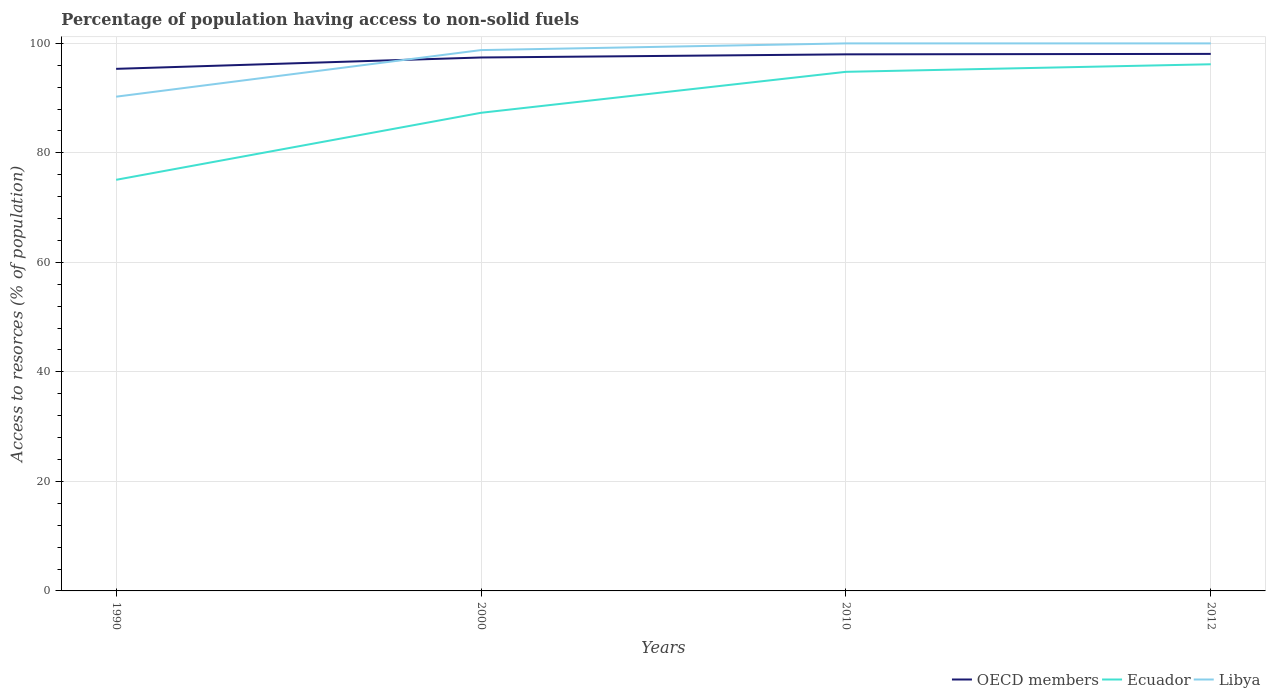Is the number of lines equal to the number of legend labels?
Your answer should be compact. Yes. Across all years, what is the maximum percentage of population having access to non-solid fuels in OECD members?
Keep it short and to the point. 95.34. What is the total percentage of population having access to non-solid fuels in Ecuador in the graph?
Offer a terse response. -21.1. What is the difference between the highest and the second highest percentage of population having access to non-solid fuels in Ecuador?
Offer a terse response. 21.1. What is the difference between the highest and the lowest percentage of population having access to non-solid fuels in Libya?
Make the answer very short. 3. Is the percentage of population having access to non-solid fuels in OECD members strictly greater than the percentage of population having access to non-solid fuels in Ecuador over the years?
Make the answer very short. No. Are the values on the major ticks of Y-axis written in scientific E-notation?
Give a very brief answer. No. Where does the legend appear in the graph?
Make the answer very short. Bottom right. How many legend labels are there?
Make the answer very short. 3. How are the legend labels stacked?
Offer a terse response. Horizontal. What is the title of the graph?
Your answer should be compact. Percentage of population having access to non-solid fuels. Does "Solomon Islands" appear as one of the legend labels in the graph?
Offer a very short reply. No. What is the label or title of the X-axis?
Provide a succinct answer. Years. What is the label or title of the Y-axis?
Keep it short and to the point. Access to resorces (% of population). What is the Access to resorces (% of population) in OECD members in 1990?
Make the answer very short. 95.34. What is the Access to resorces (% of population) in Ecuador in 1990?
Make the answer very short. 75.08. What is the Access to resorces (% of population) of Libya in 1990?
Offer a very short reply. 90.26. What is the Access to resorces (% of population) of OECD members in 2000?
Provide a short and direct response. 97.42. What is the Access to resorces (% of population) of Ecuador in 2000?
Offer a very short reply. 87.32. What is the Access to resorces (% of population) in Libya in 2000?
Provide a short and direct response. 98.77. What is the Access to resorces (% of population) of OECD members in 2010?
Your answer should be very brief. 97.99. What is the Access to resorces (% of population) in Ecuador in 2010?
Provide a short and direct response. 94.8. What is the Access to resorces (% of population) of Libya in 2010?
Give a very brief answer. 99.99. What is the Access to resorces (% of population) of OECD members in 2012?
Provide a short and direct response. 98.07. What is the Access to resorces (% of population) in Ecuador in 2012?
Offer a very short reply. 96.18. What is the Access to resorces (% of population) in Libya in 2012?
Give a very brief answer. 99.99. Across all years, what is the maximum Access to resorces (% of population) of OECD members?
Your response must be concise. 98.07. Across all years, what is the maximum Access to resorces (% of population) in Ecuador?
Give a very brief answer. 96.18. Across all years, what is the maximum Access to resorces (% of population) of Libya?
Make the answer very short. 99.99. Across all years, what is the minimum Access to resorces (% of population) in OECD members?
Provide a succinct answer. 95.34. Across all years, what is the minimum Access to resorces (% of population) in Ecuador?
Provide a succinct answer. 75.08. Across all years, what is the minimum Access to resorces (% of population) in Libya?
Keep it short and to the point. 90.26. What is the total Access to resorces (% of population) in OECD members in the graph?
Your response must be concise. 388.83. What is the total Access to resorces (% of population) of Ecuador in the graph?
Provide a succinct answer. 353.37. What is the total Access to resorces (% of population) of Libya in the graph?
Provide a succinct answer. 389.01. What is the difference between the Access to resorces (% of population) of OECD members in 1990 and that in 2000?
Ensure brevity in your answer.  -2.07. What is the difference between the Access to resorces (% of population) of Ecuador in 1990 and that in 2000?
Your answer should be very brief. -12.24. What is the difference between the Access to resorces (% of population) in Libya in 1990 and that in 2000?
Offer a very short reply. -8.51. What is the difference between the Access to resorces (% of population) in OECD members in 1990 and that in 2010?
Give a very brief answer. -2.65. What is the difference between the Access to resorces (% of population) of Ecuador in 1990 and that in 2010?
Ensure brevity in your answer.  -19.72. What is the difference between the Access to resorces (% of population) in Libya in 1990 and that in 2010?
Your response must be concise. -9.73. What is the difference between the Access to resorces (% of population) of OECD members in 1990 and that in 2012?
Your answer should be compact. -2.73. What is the difference between the Access to resorces (% of population) of Ecuador in 1990 and that in 2012?
Ensure brevity in your answer.  -21.1. What is the difference between the Access to resorces (% of population) in Libya in 1990 and that in 2012?
Make the answer very short. -9.73. What is the difference between the Access to resorces (% of population) of OECD members in 2000 and that in 2010?
Ensure brevity in your answer.  -0.57. What is the difference between the Access to resorces (% of population) of Ecuador in 2000 and that in 2010?
Ensure brevity in your answer.  -7.48. What is the difference between the Access to resorces (% of population) of Libya in 2000 and that in 2010?
Provide a succinct answer. -1.22. What is the difference between the Access to resorces (% of population) of OECD members in 2000 and that in 2012?
Keep it short and to the point. -0.66. What is the difference between the Access to resorces (% of population) of Ecuador in 2000 and that in 2012?
Offer a very short reply. -8.86. What is the difference between the Access to resorces (% of population) of Libya in 2000 and that in 2012?
Offer a terse response. -1.22. What is the difference between the Access to resorces (% of population) in OECD members in 2010 and that in 2012?
Your answer should be very brief. -0.08. What is the difference between the Access to resorces (% of population) of Ecuador in 2010 and that in 2012?
Your answer should be compact. -1.38. What is the difference between the Access to resorces (% of population) in OECD members in 1990 and the Access to resorces (% of population) in Ecuador in 2000?
Ensure brevity in your answer.  8.03. What is the difference between the Access to resorces (% of population) in OECD members in 1990 and the Access to resorces (% of population) in Libya in 2000?
Keep it short and to the point. -3.42. What is the difference between the Access to resorces (% of population) of Ecuador in 1990 and the Access to resorces (% of population) of Libya in 2000?
Offer a very short reply. -23.69. What is the difference between the Access to resorces (% of population) in OECD members in 1990 and the Access to resorces (% of population) in Ecuador in 2010?
Your answer should be very brief. 0.55. What is the difference between the Access to resorces (% of population) in OECD members in 1990 and the Access to resorces (% of population) in Libya in 2010?
Provide a short and direct response. -4.65. What is the difference between the Access to resorces (% of population) in Ecuador in 1990 and the Access to resorces (% of population) in Libya in 2010?
Your answer should be very brief. -24.91. What is the difference between the Access to resorces (% of population) of OECD members in 1990 and the Access to resorces (% of population) of Ecuador in 2012?
Ensure brevity in your answer.  -0.83. What is the difference between the Access to resorces (% of population) of OECD members in 1990 and the Access to resorces (% of population) of Libya in 2012?
Your answer should be very brief. -4.65. What is the difference between the Access to resorces (% of population) of Ecuador in 1990 and the Access to resorces (% of population) of Libya in 2012?
Provide a succinct answer. -24.91. What is the difference between the Access to resorces (% of population) of OECD members in 2000 and the Access to resorces (% of population) of Ecuador in 2010?
Offer a terse response. 2.62. What is the difference between the Access to resorces (% of population) in OECD members in 2000 and the Access to resorces (% of population) in Libya in 2010?
Offer a terse response. -2.57. What is the difference between the Access to resorces (% of population) of Ecuador in 2000 and the Access to resorces (% of population) of Libya in 2010?
Offer a very short reply. -12.67. What is the difference between the Access to resorces (% of population) of OECD members in 2000 and the Access to resorces (% of population) of Ecuador in 2012?
Offer a terse response. 1.24. What is the difference between the Access to resorces (% of population) in OECD members in 2000 and the Access to resorces (% of population) in Libya in 2012?
Make the answer very short. -2.57. What is the difference between the Access to resorces (% of population) of Ecuador in 2000 and the Access to resorces (% of population) of Libya in 2012?
Offer a terse response. -12.67. What is the difference between the Access to resorces (% of population) in OECD members in 2010 and the Access to resorces (% of population) in Ecuador in 2012?
Provide a succinct answer. 1.81. What is the difference between the Access to resorces (% of population) of OECD members in 2010 and the Access to resorces (% of population) of Libya in 2012?
Your answer should be compact. -2. What is the difference between the Access to resorces (% of population) in Ecuador in 2010 and the Access to resorces (% of population) in Libya in 2012?
Ensure brevity in your answer.  -5.19. What is the average Access to resorces (% of population) in OECD members per year?
Provide a short and direct response. 97.21. What is the average Access to resorces (% of population) in Ecuador per year?
Your answer should be very brief. 88.34. What is the average Access to resorces (% of population) of Libya per year?
Provide a short and direct response. 97.25. In the year 1990, what is the difference between the Access to resorces (% of population) of OECD members and Access to resorces (% of population) of Ecuador?
Offer a terse response. 20.27. In the year 1990, what is the difference between the Access to resorces (% of population) in OECD members and Access to resorces (% of population) in Libya?
Your response must be concise. 5.08. In the year 1990, what is the difference between the Access to resorces (% of population) of Ecuador and Access to resorces (% of population) of Libya?
Offer a very short reply. -15.18. In the year 2000, what is the difference between the Access to resorces (% of population) in OECD members and Access to resorces (% of population) in Ecuador?
Your answer should be compact. 10.1. In the year 2000, what is the difference between the Access to resorces (% of population) of OECD members and Access to resorces (% of population) of Libya?
Provide a succinct answer. -1.35. In the year 2000, what is the difference between the Access to resorces (% of population) of Ecuador and Access to resorces (% of population) of Libya?
Offer a terse response. -11.45. In the year 2010, what is the difference between the Access to resorces (% of population) in OECD members and Access to resorces (% of population) in Ecuador?
Your answer should be very brief. 3.19. In the year 2010, what is the difference between the Access to resorces (% of population) of OECD members and Access to resorces (% of population) of Libya?
Your answer should be compact. -2. In the year 2010, what is the difference between the Access to resorces (% of population) of Ecuador and Access to resorces (% of population) of Libya?
Make the answer very short. -5.19. In the year 2012, what is the difference between the Access to resorces (% of population) in OECD members and Access to resorces (% of population) in Ecuador?
Keep it short and to the point. 1.9. In the year 2012, what is the difference between the Access to resorces (% of population) in OECD members and Access to resorces (% of population) in Libya?
Offer a very short reply. -1.92. In the year 2012, what is the difference between the Access to resorces (% of population) of Ecuador and Access to resorces (% of population) of Libya?
Give a very brief answer. -3.81. What is the ratio of the Access to resorces (% of population) of OECD members in 1990 to that in 2000?
Provide a succinct answer. 0.98. What is the ratio of the Access to resorces (% of population) in Ecuador in 1990 to that in 2000?
Your response must be concise. 0.86. What is the ratio of the Access to resorces (% of population) of Libya in 1990 to that in 2000?
Ensure brevity in your answer.  0.91. What is the ratio of the Access to resorces (% of population) of OECD members in 1990 to that in 2010?
Provide a succinct answer. 0.97. What is the ratio of the Access to resorces (% of population) of Ecuador in 1990 to that in 2010?
Your answer should be very brief. 0.79. What is the ratio of the Access to resorces (% of population) in Libya in 1990 to that in 2010?
Provide a short and direct response. 0.9. What is the ratio of the Access to resorces (% of population) of OECD members in 1990 to that in 2012?
Give a very brief answer. 0.97. What is the ratio of the Access to resorces (% of population) in Ecuador in 1990 to that in 2012?
Provide a short and direct response. 0.78. What is the ratio of the Access to resorces (% of population) in Libya in 1990 to that in 2012?
Keep it short and to the point. 0.9. What is the ratio of the Access to resorces (% of population) of OECD members in 2000 to that in 2010?
Provide a short and direct response. 0.99. What is the ratio of the Access to resorces (% of population) of Ecuador in 2000 to that in 2010?
Your response must be concise. 0.92. What is the ratio of the Access to resorces (% of population) in Ecuador in 2000 to that in 2012?
Your answer should be compact. 0.91. What is the ratio of the Access to resorces (% of population) of Libya in 2000 to that in 2012?
Your response must be concise. 0.99. What is the ratio of the Access to resorces (% of population) in OECD members in 2010 to that in 2012?
Ensure brevity in your answer.  1. What is the ratio of the Access to resorces (% of population) of Ecuador in 2010 to that in 2012?
Offer a terse response. 0.99. What is the difference between the highest and the second highest Access to resorces (% of population) of OECD members?
Provide a succinct answer. 0.08. What is the difference between the highest and the second highest Access to resorces (% of population) in Ecuador?
Your answer should be very brief. 1.38. What is the difference between the highest and the lowest Access to resorces (% of population) of OECD members?
Your answer should be compact. 2.73. What is the difference between the highest and the lowest Access to resorces (% of population) of Ecuador?
Your response must be concise. 21.1. What is the difference between the highest and the lowest Access to resorces (% of population) of Libya?
Ensure brevity in your answer.  9.73. 